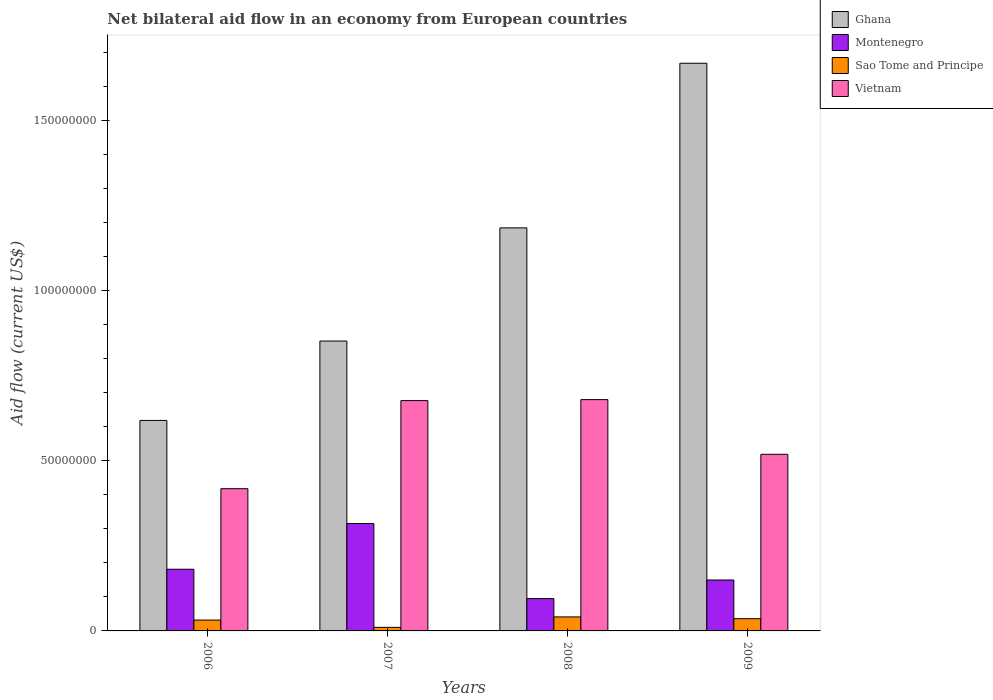How many bars are there on the 1st tick from the left?
Make the answer very short. 4. What is the label of the 2nd group of bars from the left?
Provide a succinct answer. 2007. What is the net bilateral aid flow in Ghana in 2009?
Provide a short and direct response. 1.67e+08. Across all years, what is the maximum net bilateral aid flow in Montenegro?
Provide a short and direct response. 3.16e+07. Across all years, what is the minimum net bilateral aid flow in Vietnam?
Give a very brief answer. 4.18e+07. In which year was the net bilateral aid flow in Vietnam maximum?
Your answer should be compact. 2008. What is the total net bilateral aid flow in Montenegro in the graph?
Offer a terse response. 7.42e+07. What is the difference between the net bilateral aid flow in Vietnam in 2007 and that in 2008?
Offer a terse response. -2.90e+05. What is the difference between the net bilateral aid flow in Montenegro in 2008 and the net bilateral aid flow in Vietnam in 2009?
Your answer should be compact. -4.24e+07. What is the average net bilateral aid flow in Ghana per year?
Offer a terse response. 1.08e+08. In the year 2007, what is the difference between the net bilateral aid flow in Ghana and net bilateral aid flow in Vietnam?
Provide a short and direct response. 1.75e+07. What is the ratio of the net bilateral aid flow in Ghana in 2007 to that in 2009?
Give a very brief answer. 0.51. Is the net bilateral aid flow in Ghana in 2006 less than that in 2007?
Give a very brief answer. Yes. What is the difference between the highest and the second highest net bilateral aid flow in Montenegro?
Give a very brief answer. 1.34e+07. What is the difference between the highest and the lowest net bilateral aid flow in Ghana?
Keep it short and to the point. 1.05e+08. In how many years, is the net bilateral aid flow in Sao Tome and Principe greater than the average net bilateral aid flow in Sao Tome and Principe taken over all years?
Give a very brief answer. 3. What does the 2nd bar from the left in 2006 represents?
Offer a very short reply. Montenegro. How many bars are there?
Your response must be concise. 16. Are all the bars in the graph horizontal?
Give a very brief answer. No. How many years are there in the graph?
Offer a very short reply. 4. Are the values on the major ticks of Y-axis written in scientific E-notation?
Your response must be concise. No. Where does the legend appear in the graph?
Provide a succinct answer. Top right. How many legend labels are there?
Ensure brevity in your answer.  4. What is the title of the graph?
Provide a succinct answer. Net bilateral aid flow in an economy from European countries. Does "Isle of Man" appear as one of the legend labels in the graph?
Keep it short and to the point. No. What is the label or title of the X-axis?
Offer a terse response. Years. What is the label or title of the Y-axis?
Ensure brevity in your answer.  Aid flow (current US$). What is the Aid flow (current US$) in Ghana in 2006?
Give a very brief answer. 6.19e+07. What is the Aid flow (current US$) in Montenegro in 2006?
Ensure brevity in your answer.  1.81e+07. What is the Aid flow (current US$) of Sao Tome and Principe in 2006?
Your answer should be very brief. 3.19e+06. What is the Aid flow (current US$) of Vietnam in 2006?
Give a very brief answer. 4.18e+07. What is the Aid flow (current US$) in Ghana in 2007?
Provide a short and direct response. 8.52e+07. What is the Aid flow (current US$) of Montenegro in 2007?
Your answer should be very brief. 3.16e+07. What is the Aid flow (current US$) in Sao Tome and Principe in 2007?
Your response must be concise. 1.05e+06. What is the Aid flow (current US$) in Vietnam in 2007?
Your answer should be very brief. 6.77e+07. What is the Aid flow (current US$) of Ghana in 2008?
Your answer should be very brief. 1.18e+08. What is the Aid flow (current US$) of Montenegro in 2008?
Provide a succinct answer. 9.50e+06. What is the Aid flow (current US$) of Sao Tome and Principe in 2008?
Offer a terse response. 4.12e+06. What is the Aid flow (current US$) of Vietnam in 2008?
Keep it short and to the point. 6.80e+07. What is the Aid flow (current US$) in Ghana in 2009?
Your response must be concise. 1.67e+08. What is the Aid flow (current US$) of Montenegro in 2009?
Provide a short and direct response. 1.50e+07. What is the Aid flow (current US$) of Sao Tome and Principe in 2009?
Give a very brief answer. 3.60e+06. What is the Aid flow (current US$) of Vietnam in 2009?
Provide a succinct answer. 5.19e+07. Across all years, what is the maximum Aid flow (current US$) in Ghana?
Your response must be concise. 1.67e+08. Across all years, what is the maximum Aid flow (current US$) of Montenegro?
Your answer should be very brief. 3.16e+07. Across all years, what is the maximum Aid flow (current US$) in Sao Tome and Principe?
Give a very brief answer. 4.12e+06. Across all years, what is the maximum Aid flow (current US$) of Vietnam?
Your answer should be very brief. 6.80e+07. Across all years, what is the minimum Aid flow (current US$) in Ghana?
Keep it short and to the point. 6.19e+07. Across all years, what is the minimum Aid flow (current US$) in Montenegro?
Keep it short and to the point. 9.50e+06. Across all years, what is the minimum Aid flow (current US$) of Sao Tome and Principe?
Offer a terse response. 1.05e+06. Across all years, what is the minimum Aid flow (current US$) in Vietnam?
Provide a short and direct response. 4.18e+07. What is the total Aid flow (current US$) of Ghana in the graph?
Make the answer very short. 4.32e+08. What is the total Aid flow (current US$) in Montenegro in the graph?
Make the answer very short. 7.42e+07. What is the total Aid flow (current US$) in Sao Tome and Principe in the graph?
Your response must be concise. 1.20e+07. What is the total Aid flow (current US$) of Vietnam in the graph?
Make the answer very short. 2.29e+08. What is the difference between the Aid flow (current US$) in Ghana in 2006 and that in 2007?
Offer a terse response. -2.33e+07. What is the difference between the Aid flow (current US$) in Montenegro in 2006 and that in 2007?
Your answer should be very brief. -1.34e+07. What is the difference between the Aid flow (current US$) of Sao Tome and Principe in 2006 and that in 2007?
Offer a terse response. 2.14e+06. What is the difference between the Aid flow (current US$) of Vietnam in 2006 and that in 2007?
Provide a succinct answer. -2.59e+07. What is the difference between the Aid flow (current US$) in Ghana in 2006 and that in 2008?
Ensure brevity in your answer.  -5.66e+07. What is the difference between the Aid flow (current US$) of Montenegro in 2006 and that in 2008?
Ensure brevity in your answer.  8.63e+06. What is the difference between the Aid flow (current US$) of Sao Tome and Principe in 2006 and that in 2008?
Your answer should be very brief. -9.30e+05. What is the difference between the Aid flow (current US$) of Vietnam in 2006 and that in 2008?
Keep it short and to the point. -2.62e+07. What is the difference between the Aid flow (current US$) in Ghana in 2006 and that in 2009?
Provide a short and direct response. -1.05e+08. What is the difference between the Aid flow (current US$) of Montenegro in 2006 and that in 2009?
Your answer should be very brief. 3.16e+06. What is the difference between the Aid flow (current US$) of Sao Tome and Principe in 2006 and that in 2009?
Your answer should be very brief. -4.10e+05. What is the difference between the Aid flow (current US$) in Vietnam in 2006 and that in 2009?
Offer a very short reply. -1.01e+07. What is the difference between the Aid flow (current US$) in Ghana in 2007 and that in 2008?
Your answer should be compact. -3.33e+07. What is the difference between the Aid flow (current US$) of Montenegro in 2007 and that in 2008?
Your answer should be very brief. 2.21e+07. What is the difference between the Aid flow (current US$) of Sao Tome and Principe in 2007 and that in 2008?
Offer a very short reply. -3.07e+06. What is the difference between the Aid flow (current US$) of Vietnam in 2007 and that in 2008?
Your answer should be compact. -2.90e+05. What is the difference between the Aid flow (current US$) of Ghana in 2007 and that in 2009?
Your answer should be very brief. -8.17e+07. What is the difference between the Aid flow (current US$) in Montenegro in 2007 and that in 2009?
Your answer should be compact. 1.66e+07. What is the difference between the Aid flow (current US$) in Sao Tome and Principe in 2007 and that in 2009?
Offer a terse response. -2.55e+06. What is the difference between the Aid flow (current US$) of Vietnam in 2007 and that in 2009?
Ensure brevity in your answer.  1.58e+07. What is the difference between the Aid flow (current US$) in Ghana in 2008 and that in 2009?
Make the answer very short. -4.84e+07. What is the difference between the Aid flow (current US$) of Montenegro in 2008 and that in 2009?
Offer a very short reply. -5.47e+06. What is the difference between the Aid flow (current US$) of Sao Tome and Principe in 2008 and that in 2009?
Your answer should be very brief. 5.20e+05. What is the difference between the Aid flow (current US$) in Vietnam in 2008 and that in 2009?
Give a very brief answer. 1.61e+07. What is the difference between the Aid flow (current US$) of Ghana in 2006 and the Aid flow (current US$) of Montenegro in 2007?
Provide a short and direct response. 3.03e+07. What is the difference between the Aid flow (current US$) of Ghana in 2006 and the Aid flow (current US$) of Sao Tome and Principe in 2007?
Keep it short and to the point. 6.08e+07. What is the difference between the Aid flow (current US$) in Ghana in 2006 and the Aid flow (current US$) in Vietnam in 2007?
Give a very brief answer. -5.83e+06. What is the difference between the Aid flow (current US$) of Montenegro in 2006 and the Aid flow (current US$) of Sao Tome and Principe in 2007?
Your response must be concise. 1.71e+07. What is the difference between the Aid flow (current US$) in Montenegro in 2006 and the Aid flow (current US$) in Vietnam in 2007?
Your answer should be compact. -4.96e+07. What is the difference between the Aid flow (current US$) of Sao Tome and Principe in 2006 and the Aid flow (current US$) of Vietnam in 2007?
Your answer should be compact. -6.45e+07. What is the difference between the Aid flow (current US$) in Ghana in 2006 and the Aid flow (current US$) in Montenegro in 2008?
Ensure brevity in your answer.  5.24e+07. What is the difference between the Aid flow (current US$) in Ghana in 2006 and the Aid flow (current US$) in Sao Tome and Principe in 2008?
Your answer should be compact. 5.78e+07. What is the difference between the Aid flow (current US$) in Ghana in 2006 and the Aid flow (current US$) in Vietnam in 2008?
Offer a very short reply. -6.12e+06. What is the difference between the Aid flow (current US$) in Montenegro in 2006 and the Aid flow (current US$) in Sao Tome and Principe in 2008?
Make the answer very short. 1.40e+07. What is the difference between the Aid flow (current US$) in Montenegro in 2006 and the Aid flow (current US$) in Vietnam in 2008?
Provide a short and direct response. -4.99e+07. What is the difference between the Aid flow (current US$) of Sao Tome and Principe in 2006 and the Aid flow (current US$) of Vietnam in 2008?
Offer a terse response. -6.48e+07. What is the difference between the Aid flow (current US$) of Ghana in 2006 and the Aid flow (current US$) of Montenegro in 2009?
Make the answer very short. 4.69e+07. What is the difference between the Aid flow (current US$) in Ghana in 2006 and the Aid flow (current US$) in Sao Tome and Principe in 2009?
Keep it short and to the point. 5.83e+07. What is the difference between the Aid flow (current US$) of Ghana in 2006 and the Aid flow (current US$) of Vietnam in 2009?
Provide a succinct answer. 9.96e+06. What is the difference between the Aid flow (current US$) in Montenegro in 2006 and the Aid flow (current US$) in Sao Tome and Principe in 2009?
Offer a terse response. 1.45e+07. What is the difference between the Aid flow (current US$) in Montenegro in 2006 and the Aid flow (current US$) in Vietnam in 2009?
Offer a very short reply. -3.38e+07. What is the difference between the Aid flow (current US$) of Sao Tome and Principe in 2006 and the Aid flow (current US$) of Vietnam in 2009?
Ensure brevity in your answer.  -4.87e+07. What is the difference between the Aid flow (current US$) in Ghana in 2007 and the Aid flow (current US$) in Montenegro in 2008?
Provide a short and direct response. 7.57e+07. What is the difference between the Aid flow (current US$) in Ghana in 2007 and the Aid flow (current US$) in Sao Tome and Principe in 2008?
Your answer should be compact. 8.11e+07. What is the difference between the Aid flow (current US$) in Ghana in 2007 and the Aid flow (current US$) in Vietnam in 2008?
Give a very brief answer. 1.72e+07. What is the difference between the Aid flow (current US$) of Montenegro in 2007 and the Aid flow (current US$) of Sao Tome and Principe in 2008?
Provide a short and direct response. 2.74e+07. What is the difference between the Aid flow (current US$) of Montenegro in 2007 and the Aid flow (current US$) of Vietnam in 2008?
Keep it short and to the point. -3.64e+07. What is the difference between the Aid flow (current US$) of Sao Tome and Principe in 2007 and the Aid flow (current US$) of Vietnam in 2008?
Provide a short and direct response. -6.70e+07. What is the difference between the Aid flow (current US$) of Ghana in 2007 and the Aid flow (current US$) of Montenegro in 2009?
Offer a very short reply. 7.02e+07. What is the difference between the Aid flow (current US$) of Ghana in 2007 and the Aid flow (current US$) of Sao Tome and Principe in 2009?
Make the answer very short. 8.16e+07. What is the difference between the Aid flow (current US$) of Ghana in 2007 and the Aid flow (current US$) of Vietnam in 2009?
Provide a short and direct response. 3.33e+07. What is the difference between the Aid flow (current US$) in Montenegro in 2007 and the Aid flow (current US$) in Sao Tome and Principe in 2009?
Provide a short and direct response. 2.80e+07. What is the difference between the Aid flow (current US$) of Montenegro in 2007 and the Aid flow (current US$) of Vietnam in 2009?
Your answer should be very brief. -2.04e+07. What is the difference between the Aid flow (current US$) of Sao Tome and Principe in 2007 and the Aid flow (current US$) of Vietnam in 2009?
Provide a succinct answer. -5.09e+07. What is the difference between the Aid flow (current US$) of Ghana in 2008 and the Aid flow (current US$) of Montenegro in 2009?
Your answer should be very brief. 1.04e+08. What is the difference between the Aid flow (current US$) in Ghana in 2008 and the Aid flow (current US$) in Sao Tome and Principe in 2009?
Offer a very short reply. 1.15e+08. What is the difference between the Aid flow (current US$) in Ghana in 2008 and the Aid flow (current US$) in Vietnam in 2009?
Offer a very short reply. 6.66e+07. What is the difference between the Aid flow (current US$) of Montenegro in 2008 and the Aid flow (current US$) of Sao Tome and Principe in 2009?
Offer a terse response. 5.90e+06. What is the difference between the Aid flow (current US$) of Montenegro in 2008 and the Aid flow (current US$) of Vietnam in 2009?
Your response must be concise. -4.24e+07. What is the difference between the Aid flow (current US$) in Sao Tome and Principe in 2008 and the Aid flow (current US$) in Vietnam in 2009?
Offer a terse response. -4.78e+07. What is the average Aid flow (current US$) of Ghana per year?
Your answer should be very brief. 1.08e+08. What is the average Aid flow (current US$) of Montenegro per year?
Offer a very short reply. 1.85e+07. What is the average Aid flow (current US$) of Sao Tome and Principe per year?
Your answer should be very brief. 2.99e+06. What is the average Aid flow (current US$) in Vietnam per year?
Ensure brevity in your answer.  5.74e+07. In the year 2006, what is the difference between the Aid flow (current US$) of Ghana and Aid flow (current US$) of Montenegro?
Offer a terse response. 4.38e+07. In the year 2006, what is the difference between the Aid flow (current US$) in Ghana and Aid flow (current US$) in Sao Tome and Principe?
Your response must be concise. 5.87e+07. In the year 2006, what is the difference between the Aid flow (current US$) in Ghana and Aid flow (current US$) in Vietnam?
Provide a succinct answer. 2.01e+07. In the year 2006, what is the difference between the Aid flow (current US$) in Montenegro and Aid flow (current US$) in Sao Tome and Principe?
Give a very brief answer. 1.49e+07. In the year 2006, what is the difference between the Aid flow (current US$) of Montenegro and Aid flow (current US$) of Vietnam?
Give a very brief answer. -2.37e+07. In the year 2006, what is the difference between the Aid flow (current US$) in Sao Tome and Principe and Aid flow (current US$) in Vietnam?
Your response must be concise. -3.86e+07. In the year 2007, what is the difference between the Aid flow (current US$) of Ghana and Aid flow (current US$) of Montenegro?
Offer a very short reply. 5.36e+07. In the year 2007, what is the difference between the Aid flow (current US$) of Ghana and Aid flow (current US$) of Sao Tome and Principe?
Give a very brief answer. 8.42e+07. In the year 2007, what is the difference between the Aid flow (current US$) of Ghana and Aid flow (current US$) of Vietnam?
Offer a terse response. 1.75e+07. In the year 2007, what is the difference between the Aid flow (current US$) of Montenegro and Aid flow (current US$) of Sao Tome and Principe?
Make the answer very short. 3.05e+07. In the year 2007, what is the difference between the Aid flow (current US$) of Montenegro and Aid flow (current US$) of Vietnam?
Your answer should be very brief. -3.61e+07. In the year 2007, what is the difference between the Aid flow (current US$) of Sao Tome and Principe and Aid flow (current US$) of Vietnam?
Offer a terse response. -6.67e+07. In the year 2008, what is the difference between the Aid flow (current US$) of Ghana and Aid flow (current US$) of Montenegro?
Make the answer very short. 1.09e+08. In the year 2008, what is the difference between the Aid flow (current US$) of Ghana and Aid flow (current US$) of Sao Tome and Principe?
Provide a succinct answer. 1.14e+08. In the year 2008, what is the difference between the Aid flow (current US$) in Ghana and Aid flow (current US$) in Vietnam?
Make the answer very short. 5.05e+07. In the year 2008, what is the difference between the Aid flow (current US$) of Montenegro and Aid flow (current US$) of Sao Tome and Principe?
Make the answer very short. 5.38e+06. In the year 2008, what is the difference between the Aid flow (current US$) in Montenegro and Aid flow (current US$) in Vietnam?
Your answer should be very brief. -5.85e+07. In the year 2008, what is the difference between the Aid flow (current US$) of Sao Tome and Principe and Aid flow (current US$) of Vietnam?
Provide a succinct answer. -6.39e+07. In the year 2009, what is the difference between the Aid flow (current US$) in Ghana and Aid flow (current US$) in Montenegro?
Provide a short and direct response. 1.52e+08. In the year 2009, what is the difference between the Aid flow (current US$) of Ghana and Aid flow (current US$) of Sao Tome and Principe?
Make the answer very short. 1.63e+08. In the year 2009, what is the difference between the Aid flow (current US$) in Ghana and Aid flow (current US$) in Vietnam?
Your answer should be very brief. 1.15e+08. In the year 2009, what is the difference between the Aid flow (current US$) of Montenegro and Aid flow (current US$) of Sao Tome and Principe?
Your answer should be compact. 1.14e+07. In the year 2009, what is the difference between the Aid flow (current US$) of Montenegro and Aid flow (current US$) of Vietnam?
Provide a short and direct response. -3.70e+07. In the year 2009, what is the difference between the Aid flow (current US$) of Sao Tome and Principe and Aid flow (current US$) of Vietnam?
Your answer should be very brief. -4.83e+07. What is the ratio of the Aid flow (current US$) in Ghana in 2006 to that in 2007?
Offer a very short reply. 0.73. What is the ratio of the Aid flow (current US$) in Montenegro in 2006 to that in 2007?
Your answer should be very brief. 0.57. What is the ratio of the Aid flow (current US$) of Sao Tome and Principe in 2006 to that in 2007?
Give a very brief answer. 3.04. What is the ratio of the Aid flow (current US$) in Vietnam in 2006 to that in 2007?
Your answer should be very brief. 0.62. What is the ratio of the Aid flow (current US$) of Ghana in 2006 to that in 2008?
Your answer should be compact. 0.52. What is the ratio of the Aid flow (current US$) in Montenegro in 2006 to that in 2008?
Ensure brevity in your answer.  1.91. What is the ratio of the Aid flow (current US$) in Sao Tome and Principe in 2006 to that in 2008?
Your answer should be very brief. 0.77. What is the ratio of the Aid flow (current US$) in Vietnam in 2006 to that in 2008?
Make the answer very short. 0.61. What is the ratio of the Aid flow (current US$) of Ghana in 2006 to that in 2009?
Give a very brief answer. 0.37. What is the ratio of the Aid flow (current US$) in Montenegro in 2006 to that in 2009?
Offer a terse response. 1.21. What is the ratio of the Aid flow (current US$) of Sao Tome and Principe in 2006 to that in 2009?
Your answer should be very brief. 0.89. What is the ratio of the Aid flow (current US$) in Vietnam in 2006 to that in 2009?
Keep it short and to the point. 0.81. What is the ratio of the Aid flow (current US$) in Ghana in 2007 to that in 2008?
Your response must be concise. 0.72. What is the ratio of the Aid flow (current US$) in Montenegro in 2007 to that in 2008?
Give a very brief answer. 3.32. What is the ratio of the Aid flow (current US$) in Sao Tome and Principe in 2007 to that in 2008?
Offer a very short reply. 0.25. What is the ratio of the Aid flow (current US$) in Vietnam in 2007 to that in 2008?
Give a very brief answer. 1. What is the ratio of the Aid flow (current US$) of Ghana in 2007 to that in 2009?
Give a very brief answer. 0.51. What is the ratio of the Aid flow (current US$) in Montenegro in 2007 to that in 2009?
Offer a very short reply. 2.11. What is the ratio of the Aid flow (current US$) of Sao Tome and Principe in 2007 to that in 2009?
Your response must be concise. 0.29. What is the ratio of the Aid flow (current US$) of Vietnam in 2007 to that in 2009?
Ensure brevity in your answer.  1.3. What is the ratio of the Aid flow (current US$) of Ghana in 2008 to that in 2009?
Provide a succinct answer. 0.71. What is the ratio of the Aid flow (current US$) of Montenegro in 2008 to that in 2009?
Provide a short and direct response. 0.63. What is the ratio of the Aid flow (current US$) in Sao Tome and Principe in 2008 to that in 2009?
Provide a short and direct response. 1.14. What is the ratio of the Aid flow (current US$) in Vietnam in 2008 to that in 2009?
Your answer should be very brief. 1.31. What is the difference between the highest and the second highest Aid flow (current US$) in Ghana?
Your response must be concise. 4.84e+07. What is the difference between the highest and the second highest Aid flow (current US$) of Montenegro?
Offer a terse response. 1.34e+07. What is the difference between the highest and the second highest Aid flow (current US$) of Sao Tome and Principe?
Provide a succinct answer. 5.20e+05. What is the difference between the highest and the second highest Aid flow (current US$) of Vietnam?
Give a very brief answer. 2.90e+05. What is the difference between the highest and the lowest Aid flow (current US$) of Ghana?
Offer a very short reply. 1.05e+08. What is the difference between the highest and the lowest Aid flow (current US$) in Montenegro?
Ensure brevity in your answer.  2.21e+07. What is the difference between the highest and the lowest Aid flow (current US$) of Sao Tome and Principe?
Keep it short and to the point. 3.07e+06. What is the difference between the highest and the lowest Aid flow (current US$) in Vietnam?
Make the answer very short. 2.62e+07. 